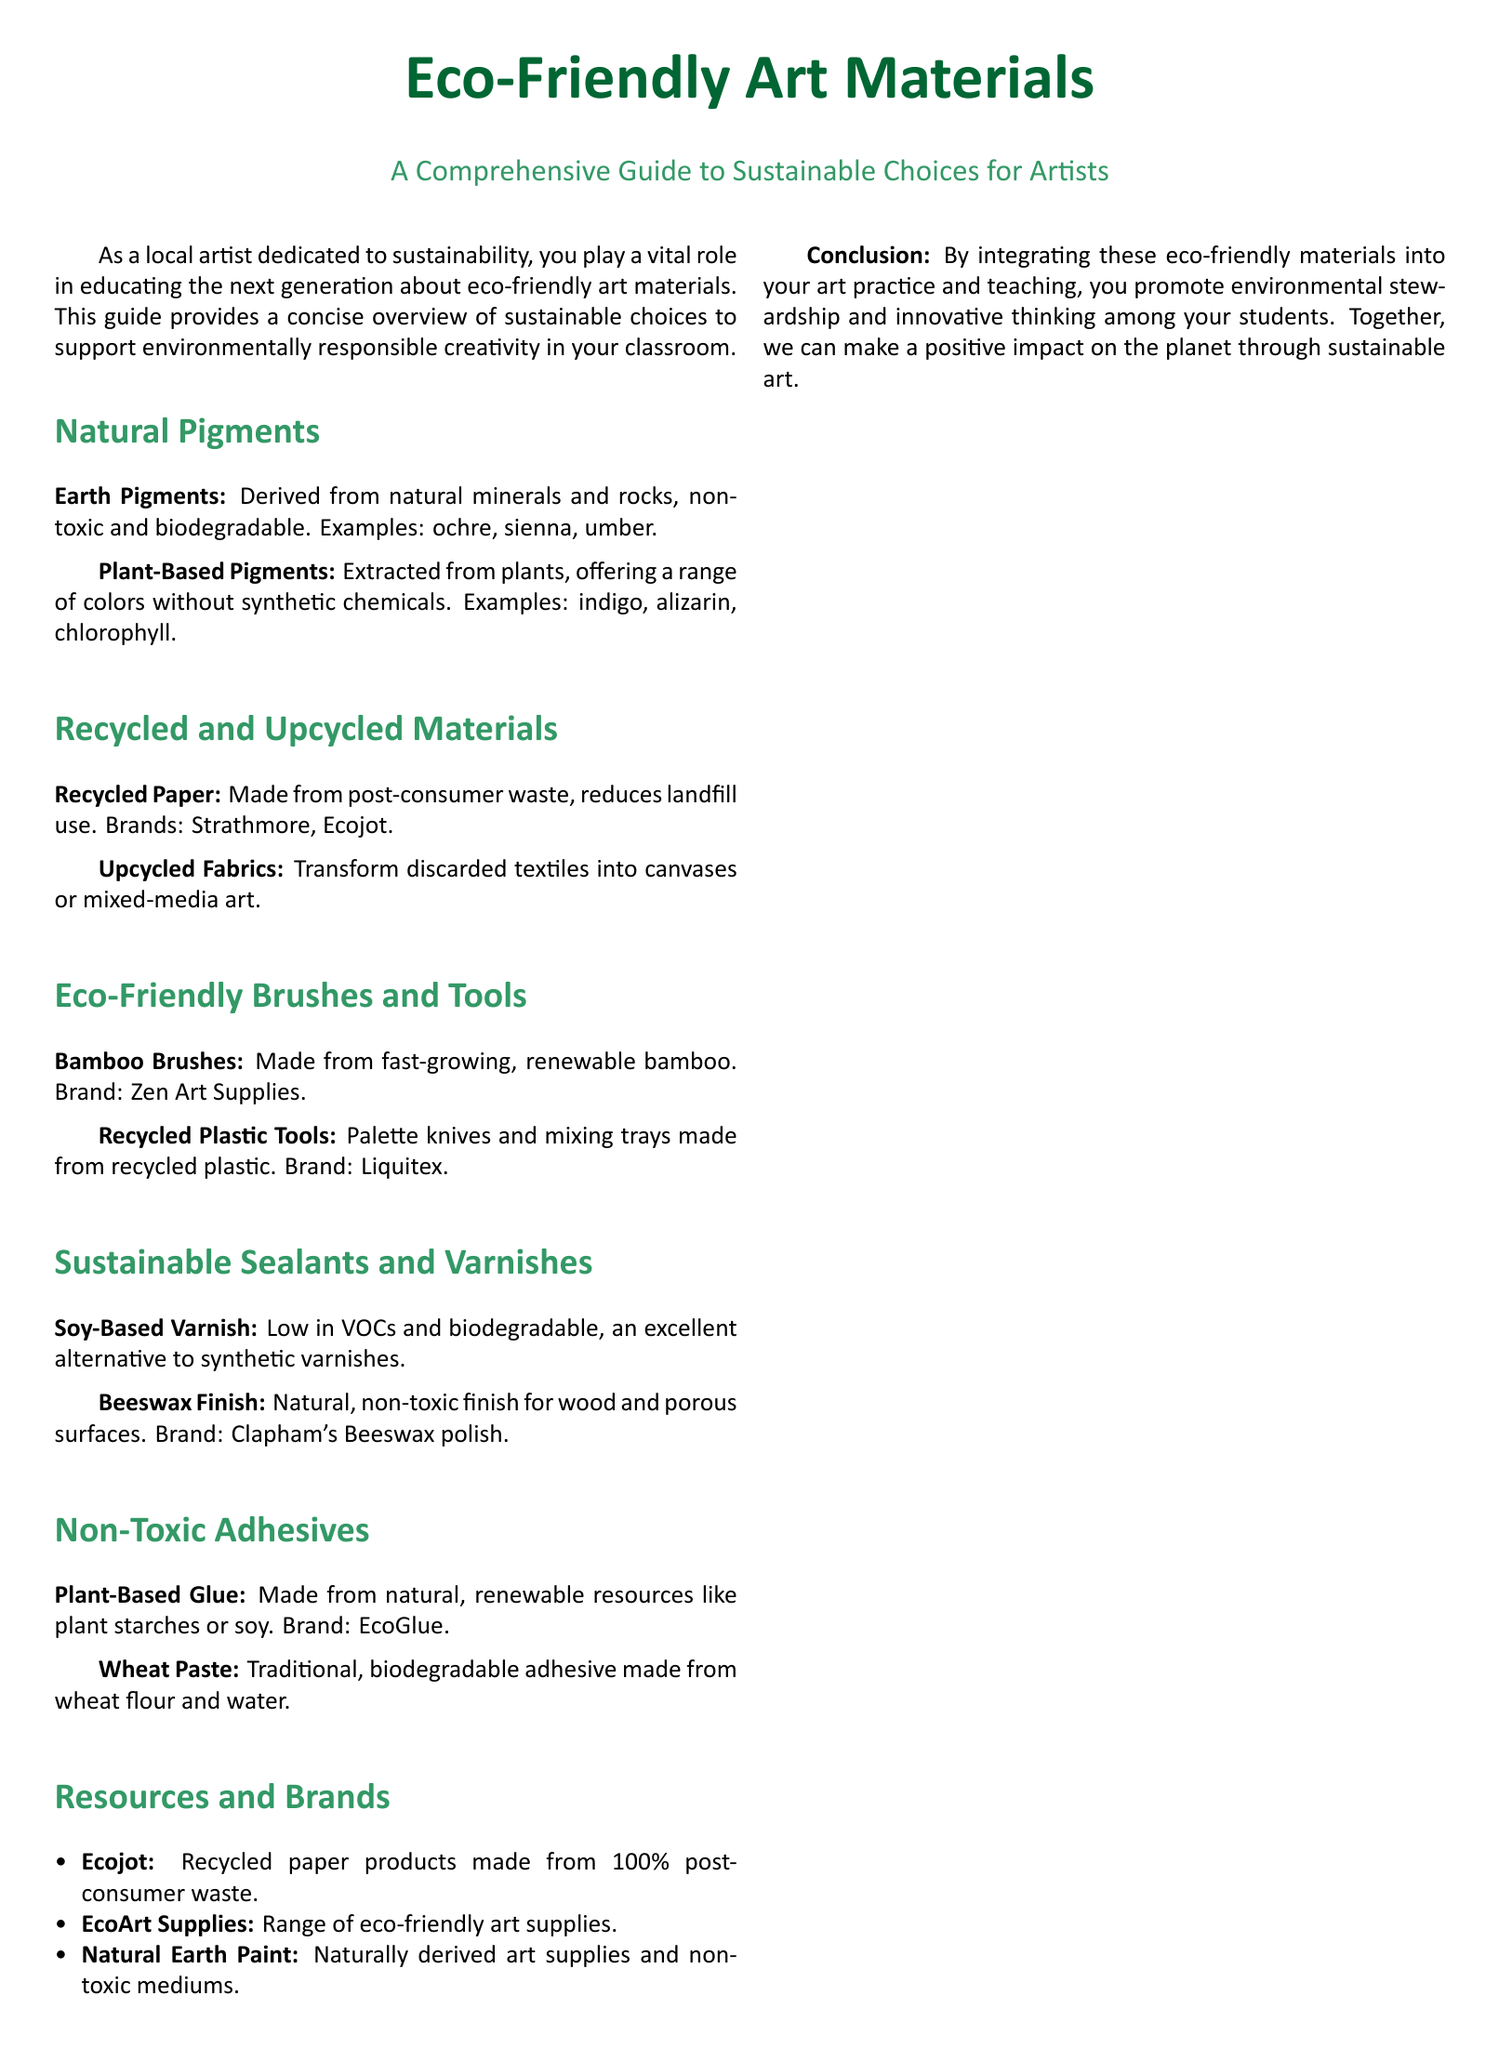What are earth pigments? Earth pigments are derived from natural minerals and rocks, non-toxic and biodegradable.
Answer: Derived from natural minerals and rocks Give an example of a plant-based pigment. The document lists plant-based pigments, including indigo, alizarin, and chlorophyll.
Answer: Indigo What type of brush is made from renewable bamboo? The document mentions bamboo brushes as a type of eco-friendly brush.
Answer: Bamboo Brushes What is a low VOC alternative to synthetic varnishes? The document suggests soy-based varnish as a sustainable option with low VOCs.
Answer: Soy-Based Varnish What adhesive is made from wheat flour? Wheat paste is described in the document as a traditional biodegradable adhesive made from wheat flour and water.
Answer: Wheat Paste Which brand offers recycled paper products? Ecojot is listed in the document as a brand that provides recycled paper products.
Answer: Ecojot What is the conclusion of the document? The conclusion emphasizes the integration of eco-friendly materials into art practice to promote environmental stewardship.
Answer: Promote environmental stewardship How many eco-friendly paint options are listed? There are two sections discussing natural pigments (earth and plant-based) with at least two examples each.
Answer: Four examples What type of finish is described as natural and non-toxic for wood surfaces? The document mentions beeswax finish as a natural and non-toxic option for wood.
Answer: Beeswax Finish 